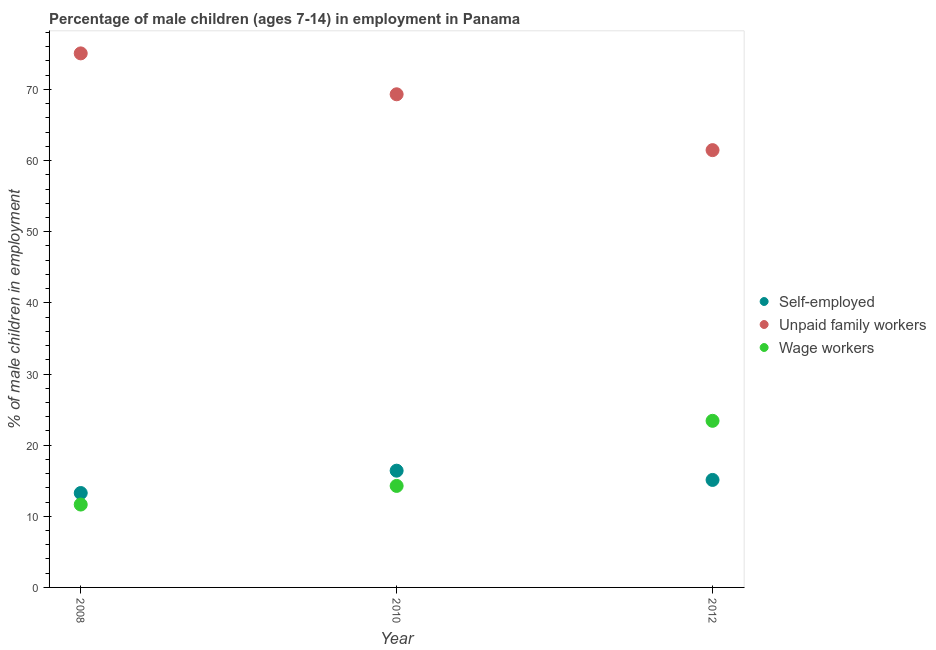How many different coloured dotlines are there?
Offer a very short reply. 3. What is the percentage of children employed as unpaid family workers in 2010?
Keep it short and to the point. 69.32. Across all years, what is the maximum percentage of children employed as wage workers?
Offer a terse response. 23.42. Across all years, what is the minimum percentage of children employed as unpaid family workers?
Make the answer very short. 61.47. In which year was the percentage of self employed children maximum?
Provide a succinct answer. 2010. In which year was the percentage of self employed children minimum?
Offer a very short reply. 2008. What is the total percentage of children employed as unpaid family workers in the graph?
Make the answer very short. 205.86. What is the difference between the percentage of children employed as unpaid family workers in 2010 and that in 2012?
Offer a very short reply. 7.85. What is the difference between the percentage of children employed as unpaid family workers in 2010 and the percentage of children employed as wage workers in 2008?
Keep it short and to the point. 57.67. What is the average percentage of self employed children per year?
Ensure brevity in your answer.  14.93. In the year 2008, what is the difference between the percentage of self employed children and percentage of children employed as unpaid family workers?
Ensure brevity in your answer.  -61.8. What is the ratio of the percentage of self employed children in 2010 to that in 2012?
Your answer should be very brief. 1.09. What is the difference between the highest and the second highest percentage of children employed as unpaid family workers?
Offer a terse response. 5.75. What is the difference between the highest and the lowest percentage of children employed as unpaid family workers?
Your answer should be very brief. 13.6. Is the sum of the percentage of self employed children in 2008 and 2010 greater than the maximum percentage of children employed as unpaid family workers across all years?
Provide a short and direct response. No. Is it the case that in every year, the sum of the percentage of self employed children and percentage of children employed as unpaid family workers is greater than the percentage of children employed as wage workers?
Your answer should be compact. Yes. Is the percentage of children employed as wage workers strictly less than the percentage of children employed as unpaid family workers over the years?
Provide a short and direct response. Yes. How many dotlines are there?
Offer a terse response. 3. How many years are there in the graph?
Offer a terse response. 3. Does the graph contain any zero values?
Provide a succinct answer. No. Where does the legend appear in the graph?
Offer a terse response. Center right. How many legend labels are there?
Provide a short and direct response. 3. How are the legend labels stacked?
Your response must be concise. Vertical. What is the title of the graph?
Provide a succinct answer. Percentage of male children (ages 7-14) in employment in Panama. What is the label or title of the Y-axis?
Your answer should be compact. % of male children in employment. What is the % of male children in employment in Self-employed in 2008?
Offer a terse response. 13.27. What is the % of male children in employment in Unpaid family workers in 2008?
Offer a very short reply. 75.07. What is the % of male children in employment in Wage workers in 2008?
Ensure brevity in your answer.  11.65. What is the % of male children in employment of Self-employed in 2010?
Offer a terse response. 16.41. What is the % of male children in employment of Unpaid family workers in 2010?
Make the answer very short. 69.32. What is the % of male children in employment of Wage workers in 2010?
Offer a very short reply. 14.27. What is the % of male children in employment of Self-employed in 2012?
Offer a very short reply. 15.11. What is the % of male children in employment in Unpaid family workers in 2012?
Provide a succinct answer. 61.47. What is the % of male children in employment in Wage workers in 2012?
Ensure brevity in your answer.  23.42. Across all years, what is the maximum % of male children in employment of Self-employed?
Your answer should be very brief. 16.41. Across all years, what is the maximum % of male children in employment of Unpaid family workers?
Your answer should be very brief. 75.07. Across all years, what is the maximum % of male children in employment of Wage workers?
Ensure brevity in your answer.  23.42. Across all years, what is the minimum % of male children in employment in Self-employed?
Your answer should be very brief. 13.27. Across all years, what is the minimum % of male children in employment in Unpaid family workers?
Your answer should be very brief. 61.47. Across all years, what is the minimum % of male children in employment of Wage workers?
Your answer should be very brief. 11.65. What is the total % of male children in employment in Self-employed in the graph?
Your response must be concise. 44.79. What is the total % of male children in employment of Unpaid family workers in the graph?
Ensure brevity in your answer.  205.86. What is the total % of male children in employment in Wage workers in the graph?
Ensure brevity in your answer.  49.34. What is the difference between the % of male children in employment in Self-employed in 2008 and that in 2010?
Your answer should be very brief. -3.14. What is the difference between the % of male children in employment of Unpaid family workers in 2008 and that in 2010?
Make the answer very short. 5.75. What is the difference between the % of male children in employment of Wage workers in 2008 and that in 2010?
Your answer should be compact. -2.62. What is the difference between the % of male children in employment of Self-employed in 2008 and that in 2012?
Your answer should be very brief. -1.84. What is the difference between the % of male children in employment in Wage workers in 2008 and that in 2012?
Provide a short and direct response. -11.77. What is the difference between the % of male children in employment of Unpaid family workers in 2010 and that in 2012?
Keep it short and to the point. 7.85. What is the difference between the % of male children in employment of Wage workers in 2010 and that in 2012?
Provide a short and direct response. -9.15. What is the difference between the % of male children in employment in Self-employed in 2008 and the % of male children in employment in Unpaid family workers in 2010?
Provide a short and direct response. -56.05. What is the difference between the % of male children in employment in Self-employed in 2008 and the % of male children in employment in Wage workers in 2010?
Ensure brevity in your answer.  -1. What is the difference between the % of male children in employment in Unpaid family workers in 2008 and the % of male children in employment in Wage workers in 2010?
Give a very brief answer. 60.8. What is the difference between the % of male children in employment of Self-employed in 2008 and the % of male children in employment of Unpaid family workers in 2012?
Keep it short and to the point. -48.2. What is the difference between the % of male children in employment of Self-employed in 2008 and the % of male children in employment of Wage workers in 2012?
Offer a terse response. -10.15. What is the difference between the % of male children in employment in Unpaid family workers in 2008 and the % of male children in employment in Wage workers in 2012?
Offer a terse response. 51.65. What is the difference between the % of male children in employment in Self-employed in 2010 and the % of male children in employment in Unpaid family workers in 2012?
Make the answer very short. -45.06. What is the difference between the % of male children in employment in Self-employed in 2010 and the % of male children in employment in Wage workers in 2012?
Your answer should be very brief. -7.01. What is the difference between the % of male children in employment of Unpaid family workers in 2010 and the % of male children in employment of Wage workers in 2012?
Provide a succinct answer. 45.9. What is the average % of male children in employment of Self-employed per year?
Make the answer very short. 14.93. What is the average % of male children in employment of Unpaid family workers per year?
Your response must be concise. 68.62. What is the average % of male children in employment in Wage workers per year?
Give a very brief answer. 16.45. In the year 2008, what is the difference between the % of male children in employment of Self-employed and % of male children in employment of Unpaid family workers?
Make the answer very short. -61.8. In the year 2008, what is the difference between the % of male children in employment of Self-employed and % of male children in employment of Wage workers?
Your answer should be very brief. 1.62. In the year 2008, what is the difference between the % of male children in employment in Unpaid family workers and % of male children in employment in Wage workers?
Offer a terse response. 63.42. In the year 2010, what is the difference between the % of male children in employment of Self-employed and % of male children in employment of Unpaid family workers?
Make the answer very short. -52.91. In the year 2010, what is the difference between the % of male children in employment in Self-employed and % of male children in employment in Wage workers?
Offer a very short reply. 2.14. In the year 2010, what is the difference between the % of male children in employment of Unpaid family workers and % of male children in employment of Wage workers?
Offer a very short reply. 55.05. In the year 2012, what is the difference between the % of male children in employment in Self-employed and % of male children in employment in Unpaid family workers?
Your answer should be compact. -46.36. In the year 2012, what is the difference between the % of male children in employment in Self-employed and % of male children in employment in Wage workers?
Provide a short and direct response. -8.31. In the year 2012, what is the difference between the % of male children in employment in Unpaid family workers and % of male children in employment in Wage workers?
Give a very brief answer. 38.05. What is the ratio of the % of male children in employment of Self-employed in 2008 to that in 2010?
Keep it short and to the point. 0.81. What is the ratio of the % of male children in employment of Unpaid family workers in 2008 to that in 2010?
Ensure brevity in your answer.  1.08. What is the ratio of the % of male children in employment of Wage workers in 2008 to that in 2010?
Ensure brevity in your answer.  0.82. What is the ratio of the % of male children in employment of Self-employed in 2008 to that in 2012?
Provide a succinct answer. 0.88. What is the ratio of the % of male children in employment of Unpaid family workers in 2008 to that in 2012?
Your response must be concise. 1.22. What is the ratio of the % of male children in employment of Wage workers in 2008 to that in 2012?
Make the answer very short. 0.5. What is the ratio of the % of male children in employment in Self-employed in 2010 to that in 2012?
Give a very brief answer. 1.09. What is the ratio of the % of male children in employment of Unpaid family workers in 2010 to that in 2012?
Offer a terse response. 1.13. What is the ratio of the % of male children in employment in Wage workers in 2010 to that in 2012?
Ensure brevity in your answer.  0.61. What is the difference between the highest and the second highest % of male children in employment of Self-employed?
Ensure brevity in your answer.  1.3. What is the difference between the highest and the second highest % of male children in employment of Unpaid family workers?
Give a very brief answer. 5.75. What is the difference between the highest and the second highest % of male children in employment of Wage workers?
Provide a short and direct response. 9.15. What is the difference between the highest and the lowest % of male children in employment in Self-employed?
Offer a terse response. 3.14. What is the difference between the highest and the lowest % of male children in employment in Wage workers?
Keep it short and to the point. 11.77. 